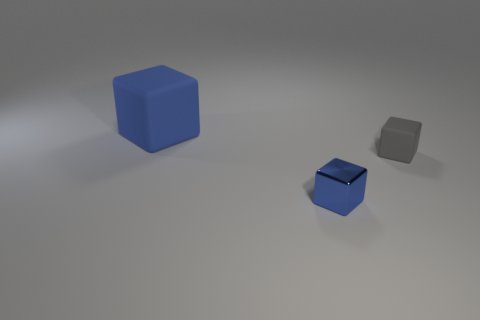What number of large matte blocks are the same color as the small shiny thing?
Your answer should be very brief. 1. How many large blue things are made of the same material as the big block?
Make the answer very short. 0. Are there more large blocks than yellow metallic blocks?
Provide a short and direct response. Yes. There is a matte object that is in front of the large cube; how many blocks are behind it?
Your answer should be compact. 1. How many objects are either rubber blocks that are behind the gray rubber thing or small gray cubes?
Your response must be concise. 2. Is there a small yellow shiny object that has the same shape as the tiny gray rubber object?
Make the answer very short. No. There is a object behind the matte block in front of the big matte object; what shape is it?
Make the answer very short. Cube. What number of balls are tiny green objects or matte objects?
Your response must be concise. 0. What material is the other cube that is the same color as the big cube?
Offer a terse response. Metal. Do the object that is on the right side of the blue metallic block and the blue thing to the right of the blue matte cube have the same shape?
Offer a very short reply. Yes. 